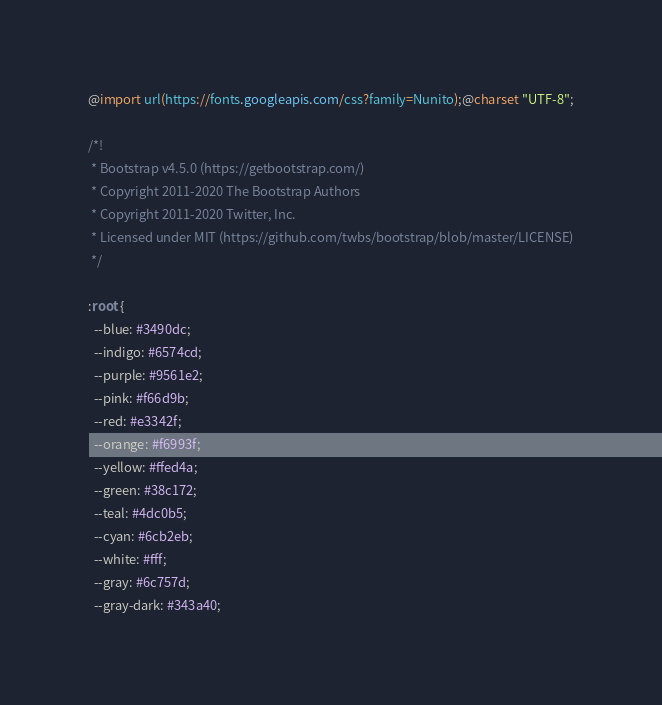<code> <loc_0><loc_0><loc_500><loc_500><_CSS_>@import url(https://fonts.googleapis.com/css?family=Nunito);@charset "UTF-8";

/*!
 * Bootstrap v4.5.0 (https://getbootstrap.com/)
 * Copyright 2011-2020 The Bootstrap Authors
 * Copyright 2011-2020 Twitter, Inc.
 * Licensed under MIT (https://github.com/twbs/bootstrap/blob/master/LICENSE)
 */

:root {
  --blue: #3490dc;
  --indigo: #6574cd;
  --purple: #9561e2;
  --pink: #f66d9b;
  --red: #e3342f;
  --orange: #f6993f;
  --yellow: #ffed4a;
  --green: #38c172;
  --teal: #4dc0b5;
  --cyan: #6cb2eb;
  --white: #fff;
  --gray: #6c757d;
  --gray-dark: #343a40;</code> 